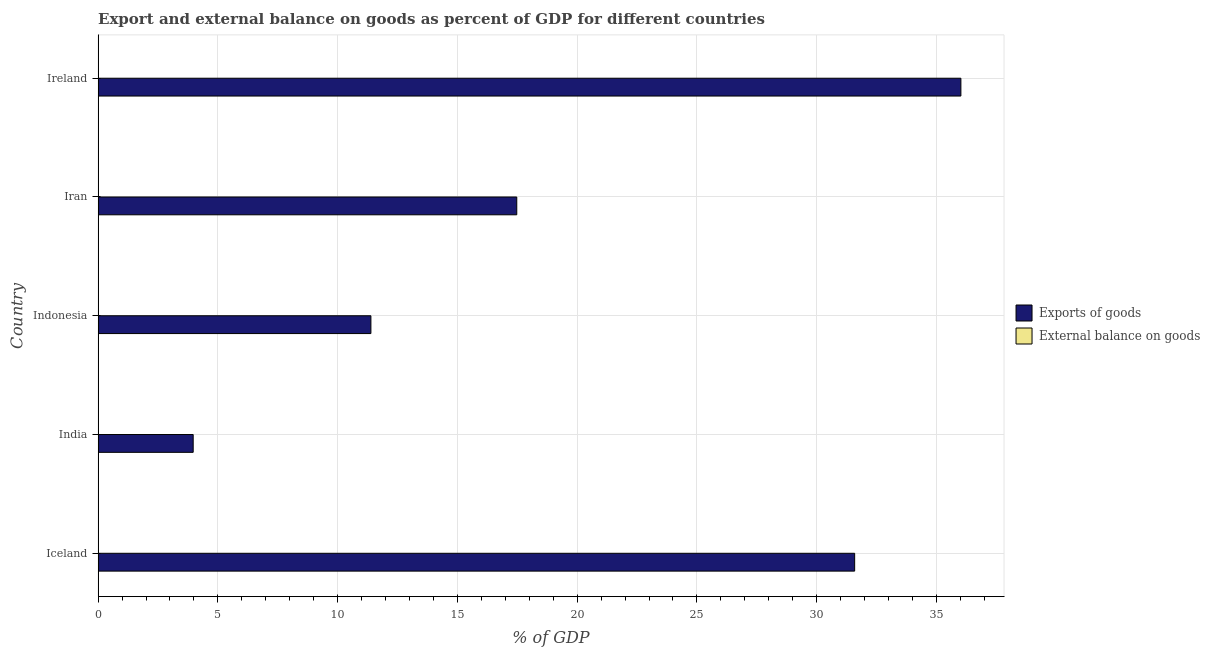Are the number of bars per tick equal to the number of legend labels?
Provide a succinct answer. No. How many bars are there on the 5th tick from the top?
Your answer should be compact. 1. How many bars are there on the 2nd tick from the bottom?
Offer a very short reply. 1. What is the label of the 1st group of bars from the top?
Provide a succinct answer. Ireland. In how many cases, is the number of bars for a given country not equal to the number of legend labels?
Make the answer very short. 5. Across all countries, what is the maximum export of goods as percentage of gdp?
Make the answer very short. 36.02. Across all countries, what is the minimum export of goods as percentage of gdp?
Offer a terse response. 3.97. In which country was the export of goods as percentage of gdp maximum?
Keep it short and to the point. Ireland. What is the difference between the export of goods as percentage of gdp in Iceland and that in Iran?
Keep it short and to the point. 14.11. What is the difference between the external balance on goods as percentage of gdp in Ireland and the export of goods as percentage of gdp in Indonesia?
Provide a short and direct response. -11.39. What is the ratio of the export of goods as percentage of gdp in Iceland to that in Iran?
Ensure brevity in your answer.  1.81. What is the difference between the highest and the second highest export of goods as percentage of gdp?
Offer a terse response. 4.43. What is the difference between the highest and the lowest export of goods as percentage of gdp?
Give a very brief answer. 32.05. How many bars are there?
Provide a succinct answer. 5. Are all the bars in the graph horizontal?
Give a very brief answer. Yes. How many countries are there in the graph?
Make the answer very short. 5. What is the difference between two consecutive major ticks on the X-axis?
Ensure brevity in your answer.  5. Are the values on the major ticks of X-axis written in scientific E-notation?
Your answer should be compact. No. Does the graph contain any zero values?
Offer a terse response. Yes. How many legend labels are there?
Give a very brief answer. 2. How are the legend labels stacked?
Provide a short and direct response. Vertical. What is the title of the graph?
Offer a terse response. Export and external balance on goods as percent of GDP for different countries. Does "DAC donors" appear as one of the legend labels in the graph?
Keep it short and to the point. No. What is the label or title of the X-axis?
Offer a terse response. % of GDP. What is the % of GDP of Exports of goods in Iceland?
Keep it short and to the point. 31.59. What is the % of GDP in External balance on goods in Iceland?
Your answer should be compact. 0. What is the % of GDP of Exports of goods in India?
Your answer should be very brief. 3.97. What is the % of GDP of External balance on goods in India?
Offer a terse response. 0. What is the % of GDP of Exports of goods in Indonesia?
Your answer should be compact. 11.39. What is the % of GDP of Exports of goods in Iran?
Make the answer very short. 17.48. What is the % of GDP of External balance on goods in Iran?
Make the answer very short. 0. What is the % of GDP in Exports of goods in Ireland?
Keep it short and to the point. 36.02. What is the % of GDP of External balance on goods in Ireland?
Your answer should be very brief. 0. Across all countries, what is the maximum % of GDP of Exports of goods?
Your answer should be compact. 36.02. Across all countries, what is the minimum % of GDP of Exports of goods?
Make the answer very short. 3.97. What is the total % of GDP of Exports of goods in the graph?
Provide a succinct answer. 100.44. What is the total % of GDP of External balance on goods in the graph?
Your response must be concise. 0. What is the difference between the % of GDP in Exports of goods in Iceland and that in India?
Give a very brief answer. 27.62. What is the difference between the % of GDP in Exports of goods in Iceland and that in Indonesia?
Ensure brevity in your answer.  20.2. What is the difference between the % of GDP in Exports of goods in Iceland and that in Iran?
Provide a short and direct response. 14.11. What is the difference between the % of GDP in Exports of goods in Iceland and that in Ireland?
Ensure brevity in your answer.  -4.44. What is the difference between the % of GDP in Exports of goods in India and that in Indonesia?
Keep it short and to the point. -7.42. What is the difference between the % of GDP in Exports of goods in India and that in Iran?
Make the answer very short. -13.51. What is the difference between the % of GDP in Exports of goods in India and that in Ireland?
Ensure brevity in your answer.  -32.05. What is the difference between the % of GDP in Exports of goods in Indonesia and that in Iran?
Make the answer very short. -6.09. What is the difference between the % of GDP of Exports of goods in Indonesia and that in Ireland?
Your answer should be compact. -24.63. What is the difference between the % of GDP of Exports of goods in Iran and that in Ireland?
Your answer should be very brief. -18.54. What is the average % of GDP in Exports of goods per country?
Your answer should be very brief. 20.09. What is the average % of GDP of External balance on goods per country?
Provide a short and direct response. 0. What is the ratio of the % of GDP in Exports of goods in Iceland to that in India?
Provide a short and direct response. 7.96. What is the ratio of the % of GDP in Exports of goods in Iceland to that in Indonesia?
Give a very brief answer. 2.77. What is the ratio of the % of GDP in Exports of goods in Iceland to that in Iran?
Keep it short and to the point. 1.81. What is the ratio of the % of GDP in Exports of goods in Iceland to that in Ireland?
Provide a short and direct response. 0.88. What is the ratio of the % of GDP of Exports of goods in India to that in Indonesia?
Your answer should be very brief. 0.35. What is the ratio of the % of GDP in Exports of goods in India to that in Iran?
Provide a succinct answer. 0.23. What is the ratio of the % of GDP of Exports of goods in India to that in Ireland?
Your response must be concise. 0.11. What is the ratio of the % of GDP in Exports of goods in Indonesia to that in Iran?
Offer a terse response. 0.65. What is the ratio of the % of GDP in Exports of goods in Indonesia to that in Ireland?
Provide a succinct answer. 0.32. What is the ratio of the % of GDP of Exports of goods in Iran to that in Ireland?
Ensure brevity in your answer.  0.49. What is the difference between the highest and the second highest % of GDP in Exports of goods?
Your answer should be very brief. 4.44. What is the difference between the highest and the lowest % of GDP of Exports of goods?
Provide a short and direct response. 32.05. 